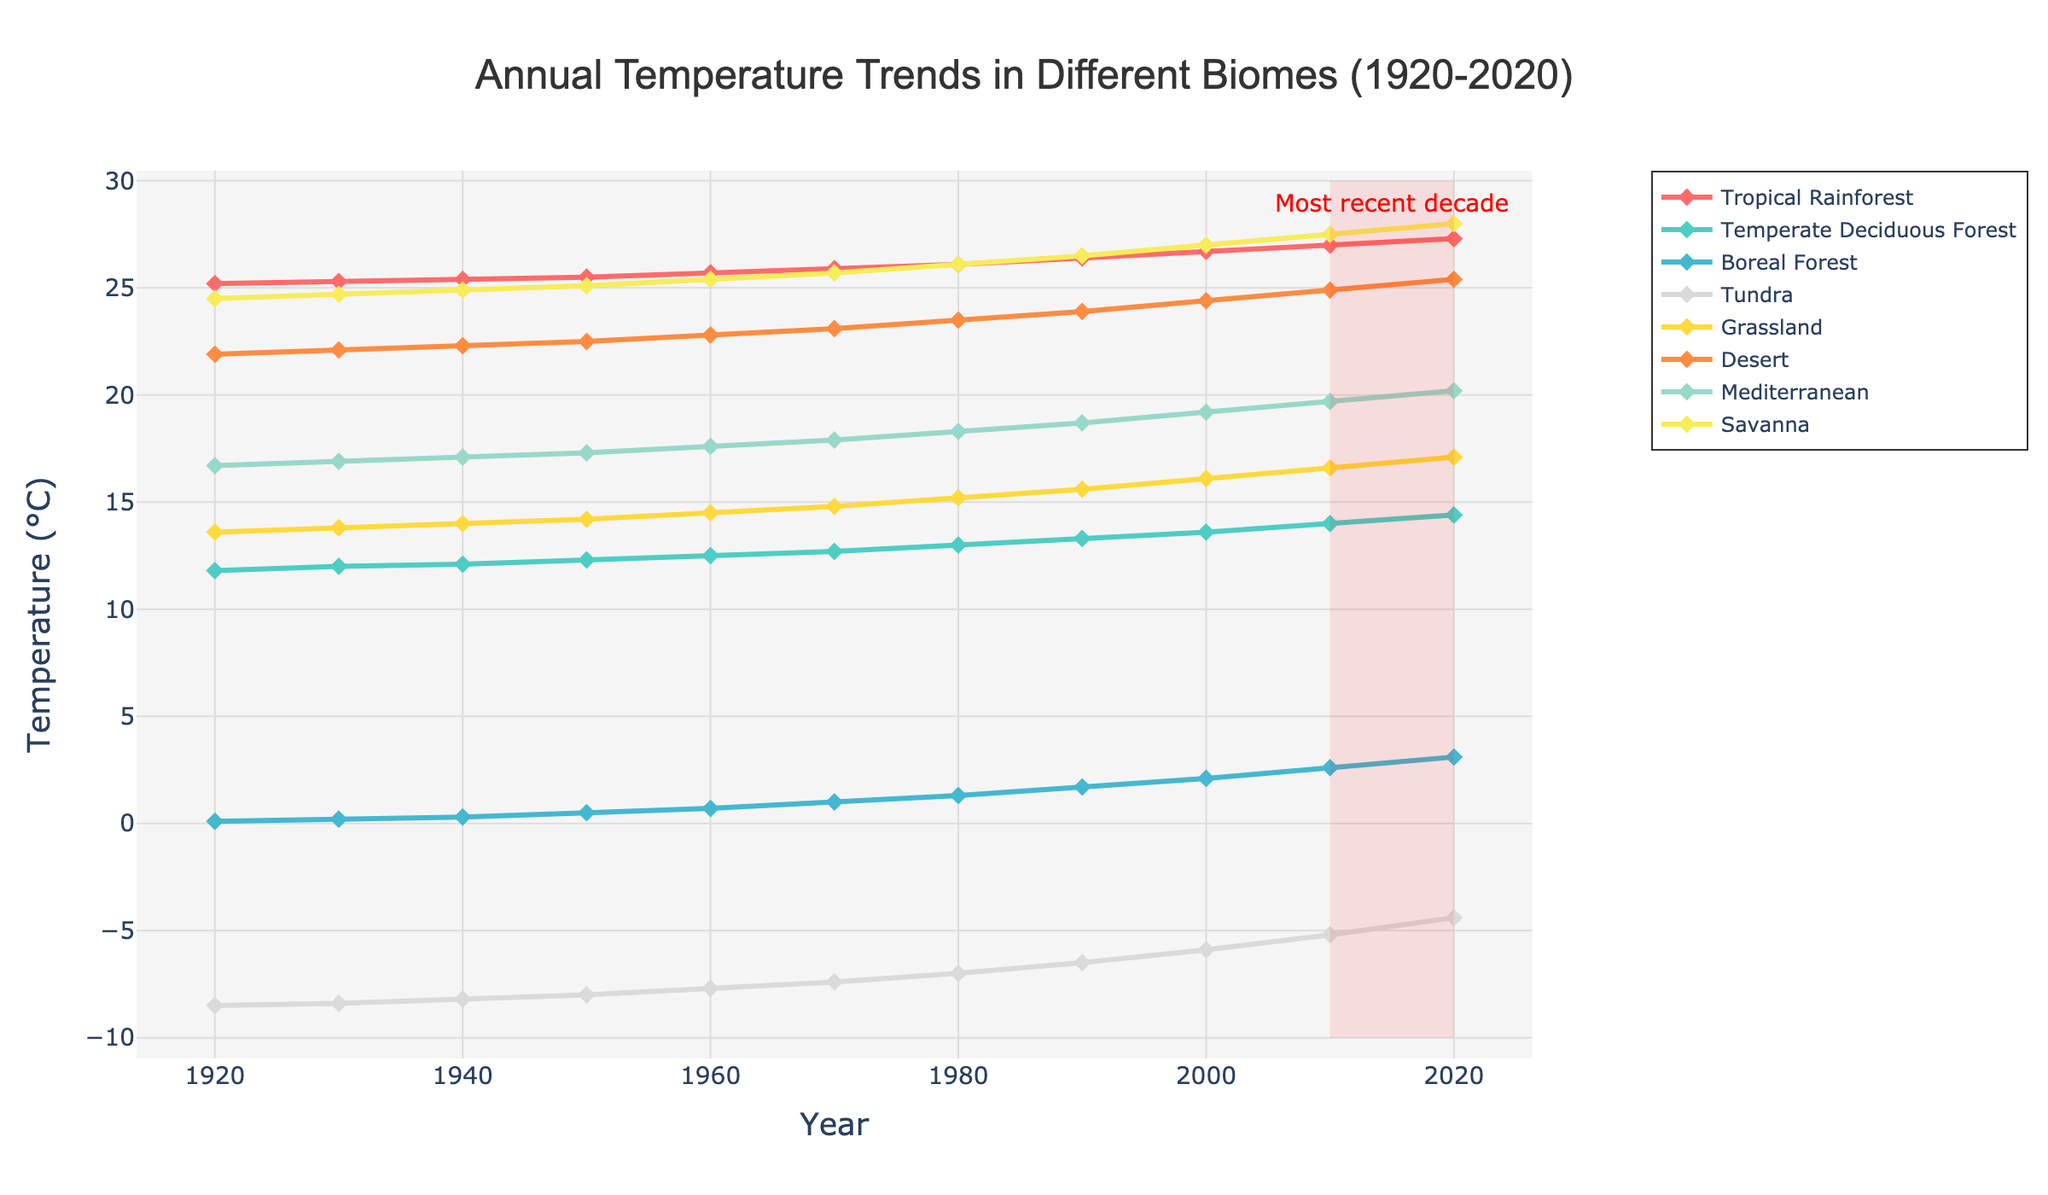What's the trend in the temperature of the Boreal Forest from 1920 to 2020? The Boreal Forest's temperature has been increasing steadily over the time period. It starts at 0.1°C in 1920 and reaches 3.1°C in 2020.
Answer: Increasing Which biome experienced the highest temperature rise over the past century? To find the highest rise, subtract the temperature in 1920 from the temperature in 2020 for each biome. The Savanna had an increase from 24.5°C to 28.0°C, a rise of 3.5°C, which is highest.
Answer: Savanna What is the average temperature in the Tundra during the first half of the century (1920-1970 inclusive)? Sum the temperatures from 1920 to 1970 and divide by the total points: (-8.5 + -8.4 + -8.2 + -8 + -7.7 + -7.4)/6 = -8.2.
Answer: -8.2°C Between which decades did the Grassland biome see the largest increase in temperature? Calculate the difference between each consecutive decade: from 1960 to 1970, 14.5 to 14.8°C, the increase is 0.3°C, from 1990 to 2000, 15.6 to 16.1°C, the increase is 0.5°C. The largest increase is between 1990 and 2000.
Answer: 1990-2000 How does the temperature change in the Desert biome compare to the Temperate Deciduous Forest between 2000 and 2020? For the Desert, from 24.4°C to 25.4°C, an increase of 1.0°C. For the Temperate Deciduous Forest, from 13.6°C to 14.4°C, an increase of 0.8°C. The Desert had a greater increase.
Answer: Desert increased more What region had the lowest temperature in 1950? The temperature in 1950 for each biome should be checked. In 1950, the Tundra has the lowest temperature at -8.0°C.
Answer: Tundra During the recent decade (2010-2020), which biomes showed an increase of more than 1°C? Subtract the temperatures from 2020 and 2010 for each biome. Tundra (-5.2 to -4.4), Grassland (16.6 to 17.1), Desert (24.9 to 25.4), and Mediterranean (19.7 to 20.2) show increases of 0.8, 0.5, 0.5, and 0.5°C; only Savanna (27.5 to 28) and Tropical Rainforest (27 to 27.3) increased.
Answer: None over 1ºC Which biomes have temperatures nearly reaching or exceeding 30°C in 2020? Check all temperatures in 2020; none exceeds or reaches 30°C.
Answer: None 